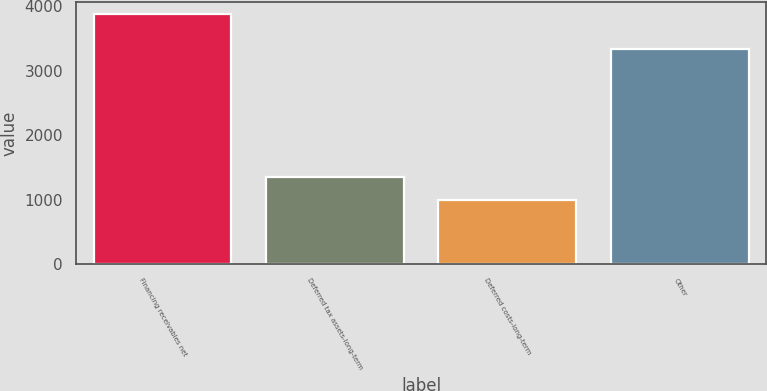Convert chart. <chart><loc_0><loc_0><loc_500><loc_500><bar_chart><fcel>Financing receivables net<fcel>Deferred tax assets-long-term<fcel>Deferred costs-long-term<fcel>Other<nl><fcel>3878<fcel>1346<fcel>999<fcel>3333<nl></chart> 